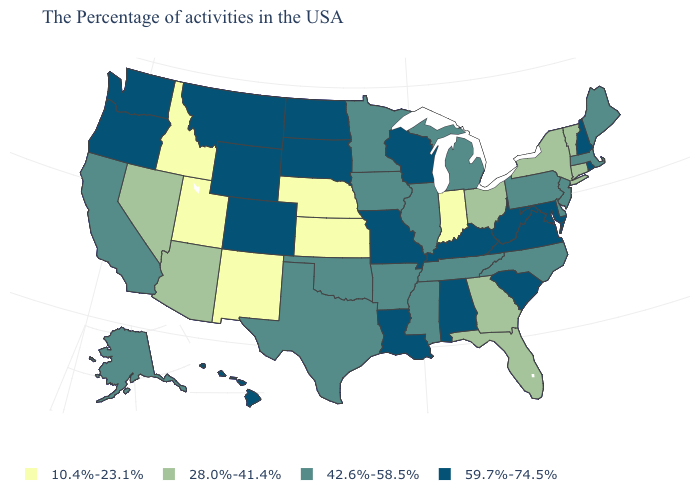What is the value of Kentucky?
Concise answer only. 59.7%-74.5%. What is the value of Kansas?
Concise answer only. 10.4%-23.1%. Among the states that border Iowa , does Illinois have the highest value?
Concise answer only. No. What is the value of Alaska?
Keep it brief. 42.6%-58.5%. Name the states that have a value in the range 28.0%-41.4%?
Short answer required. Vermont, Connecticut, New York, Ohio, Florida, Georgia, Arizona, Nevada. Which states hav the highest value in the South?
Keep it brief. Maryland, Virginia, South Carolina, West Virginia, Kentucky, Alabama, Louisiana. What is the highest value in states that border Mississippi?
Write a very short answer. 59.7%-74.5%. Does Louisiana have a higher value than Kansas?
Give a very brief answer. Yes. What is the highest value in the MidWest ?
Write a very short answer. 59.7%-74.5%. Name the states that have a value in the range 59.7%-74.5%?
Give a very brief answer. Rhode Island, New Hampshire, Maryland, Virginia, South Carolina, West Virginia, Kentucky, Alabama, Wisconsin, Louisiana, Missouri, South Dakota, North Dakota, Wyoming, Colorado, Montana, Washington, Oregon, Hawaii. Among the states that border Ohio , which have the highest value?
Give a very brief answer. West Virginia, Kentucky. Does Minnesota have a higher value than Missouri?
Give a very brief answer. No. What is the value of Kansas?
Concise answer only. 10.4%-23.1%. What is the value of Maine?
Keep it brief. 42.6%-58.5%. What is the lowest value in the USA?
Give a very brief answer. 10.4%-23.1%. 